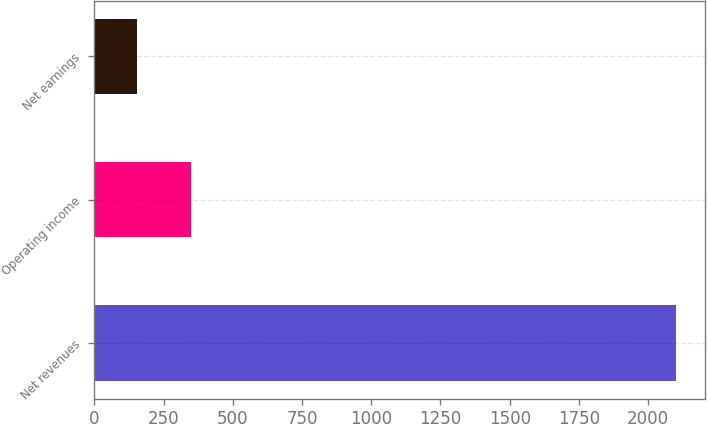<chart> <loc_0><loc_0><loc_500><loc_500><bar_chart><fcel>Net revenues<fcel>Operating income<fcel>Net earnings<nl><fcel>2100.1<fcel>350.23<fcel>155.8<nl></chart> 